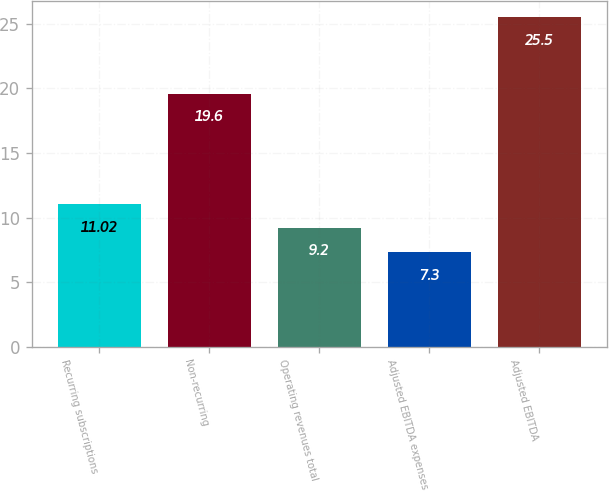Convert chart. <chart><loc_0><loc_0><loc_500><loc_500><bar_chart><fcel>Recurring subscriptions<fcel>Non-recurring<fcel>Operating revenues total<fcel>Adjusted EBITDA expenses<fcel>Adjusted EBITDA<nl><fcel>11.02<fcel>19.6<fcel>9.2<fcel>7.3<fcel>25.5<nl></chart> 